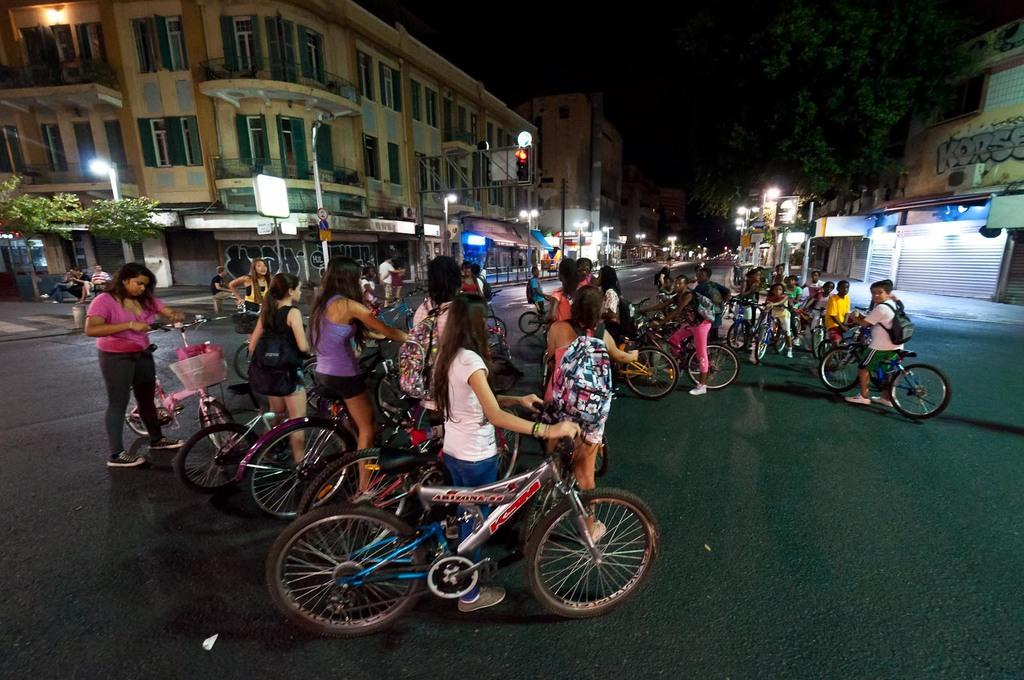What are the people on the road doing? The people on the road are holding bicycles. What can be seen in the background of the image? There are buildings, light poles, windows, and trees present in the background. How many elements can be identified in the background? There are four elements present in the background: buildings, light poles, windows, and trees. What type of letter is being delivered by the people on the road? There is no letter being delivered in the image; the people are holding bicycles. What type of produce is visible in the image? There is no produce present in the image. 